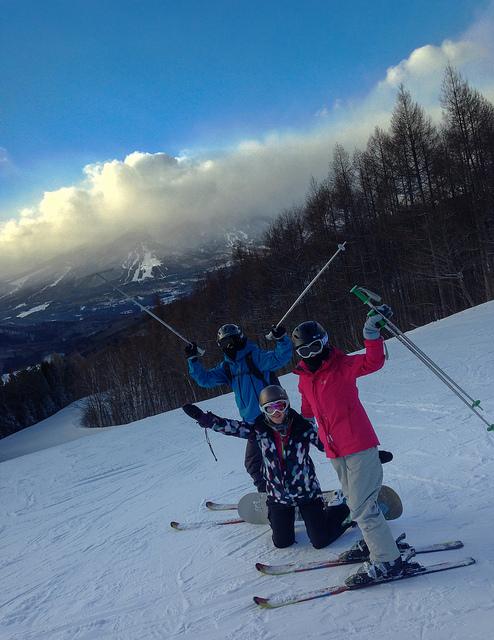What are the people holding in their hands?
Be succinct. Ski poles. Is the skiing over the edge?
Write a very short answer. No. Is the last person wearing a fanny pack?
Quick response, please. No. How many people are skiing?
Give a very brief answer. 3. Is the sport fun?
Write a very short answer. Yes. What is the white stuff on the ground?
Give a very brief answer. Snow. Is this person in the air?
Concise answer only. No. What does the child wear to keep his mouth and nose warm?
Quick response, please. Scarf. Are there people in the picture?
Short answer required. Yes. 